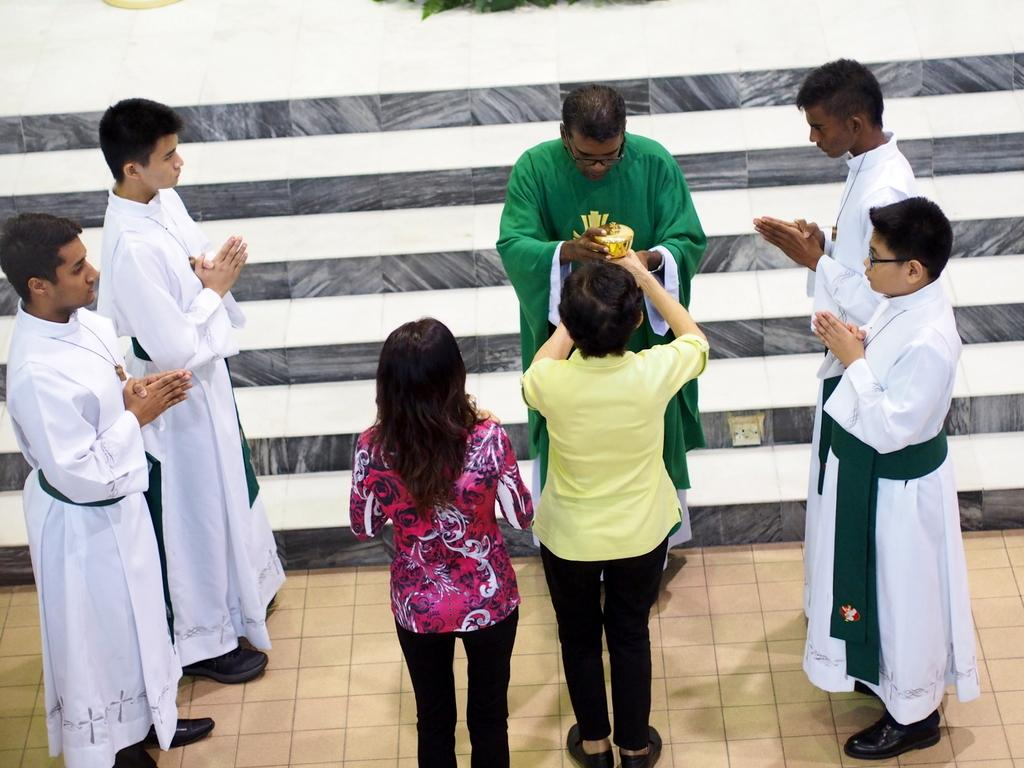What types of people are present in the image? There are men and women in the image. What is the surface that the men and women are standing on? The men and women are standing on the floor. What channel are the men and women watching in the image? There is no reference to a channel or any television in the image, so it's not possible to determine what channel might be watched. 